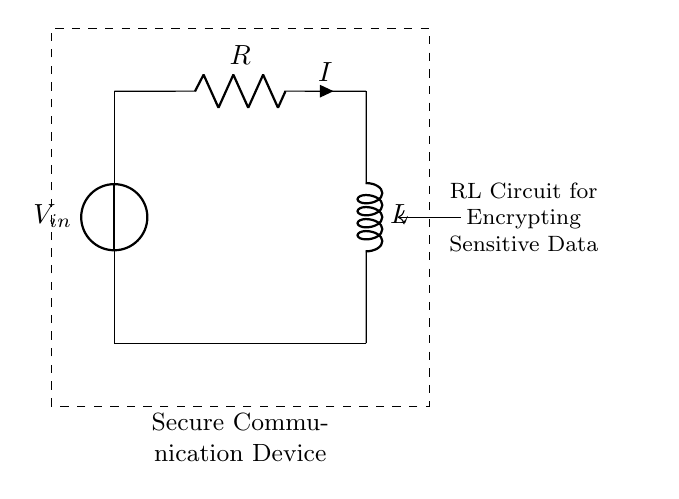What type of circuit is shown? The circuit shown is an RL circuit, which consists of a resistor and an inductor connected in series.
Answer: RL circuit What is the voltage source labeled in the diagram? The voltage source is labeled as V in the circuit diagram, representing the input voltage applied to the RL circuit.
Answer: V What does the 'R' represent in the circuit? The 'R' in the circuit represents the resistor, which is a component that limits the current flow in the circuit.
Answer: Resistor What is the meaning of 'L' in the circuit? 'L' refers to the inductor, which is a component that stores energy in a magnetic field when current flows through it.
Answer: Inductor How is the current flowing in the circuit labeled? The current flowing through the circuit is labeled as 'I', indicating the flow of electric charge due to the voltage applied.
Answer: I What effect does the inductor have on the current in the circuit? The inductor causes a delay in the current change, creating an opposition to sudden changes in current flow, which is known as inductive reactance.
Answer: Delay What type of device is this RL circuit used for? This RL circuit is used for secure communication devices to encrypt sensitive data, as indicated by the description in the diagram.
Answer: Secure communication device 